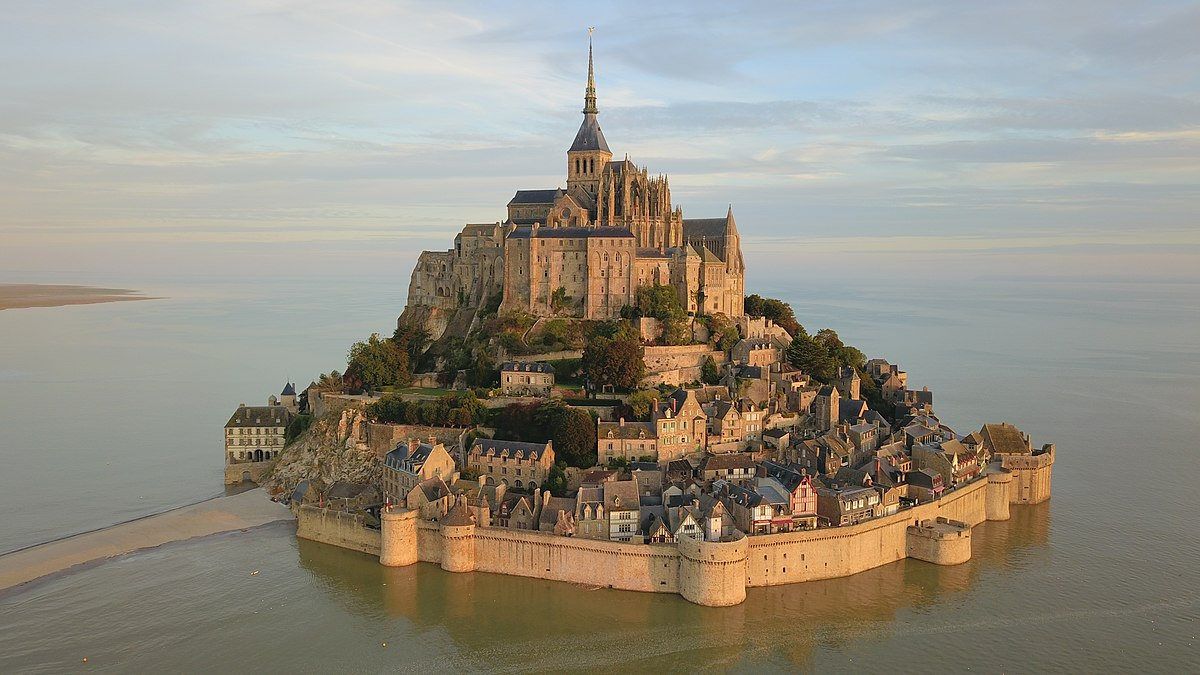How does the geography of Mont St Michel influence its historical and cultural significance? Mont St Michel's unique geographical setting on a rocky tidal island has greatly influenced its historical role and cultural narrative. Historically, its location made it easily defensible against invaders, crucial during various wars. The dramatic tides surrounding the island have added to its mystical appeal, enhancing its reputation as a site of pilgrimage and spiritual reflection. Culturally, it symbolizes resilience and strength, standing isolated but unyielding against the forces of nature and time. Its geographical isolation also contributed to its preservation as a medieval town, making it a repository of history and architecture, cherished not only by France but by the world. 